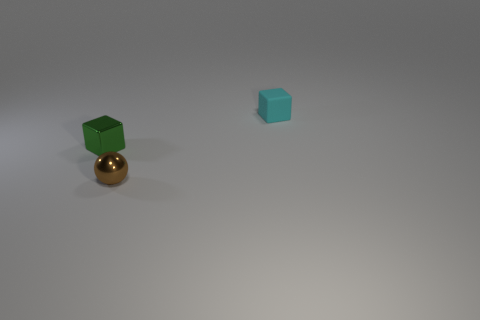Add 2 brown objects. How many objects exist? 5 Subtract all balls. How many objects are left? 2 Add 2 tiny metallic blocks. How many tiny metallic blocks are left? 3 Add 2 cyan matte things. How many cyan matte things exist? 3 Subtract 0 brown cylinders. How many objects are left? 3 Subtract all large green cubes. Subtract all green shiny cubes. How many objects are left? 2 